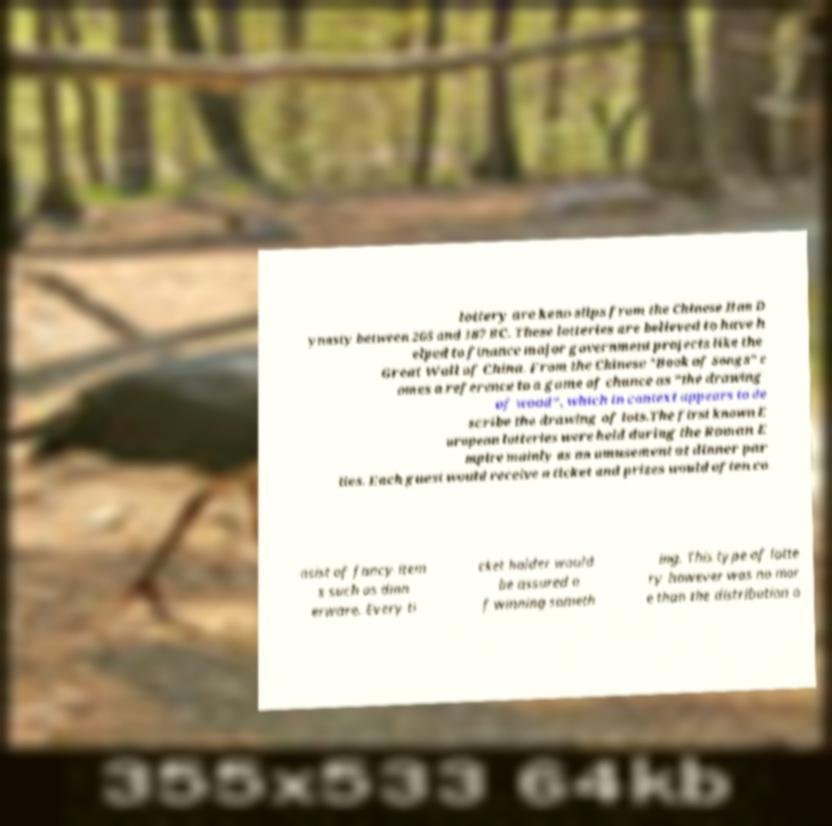I need the written content from this picture converted into text. Can you do that? lottery are keno slips from the Chinese Han D ynasty between 205 and 187 BC. These lotteries are believed to have h elped to finance major government projects like the Great Wall of China. From the Chinese "Book of Songs" c omes a reference to a game of chance as "the drawing of wood", which in context appears to de scribe the drawing of lots.The first known E uropean lotteries were held during the Roman E mpire mainly as an amusement at dinner par ties. Each guest would receive a ticket and prizes would often co nsist of fancy item s such as dinn erware. Every ti cket holder would be assured o f winning someth ing. This type of lotte ry however was no mor e than the distribution o 